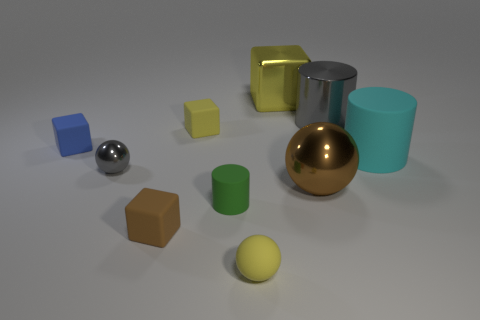Subtract all cubes. How many objects are left? 6 Subtract 0 cyan cubes. How many objects are left? 10 Subtract all metal blocks. Subtract all green rubber objects. How many objects are left? 8 Add 5 tiny yellow rubber spheres. How many tiny yellow rubber spheres are left? 6 Add 4 large yellow metal cubes. How many large yellow metal cubes exist? 5 